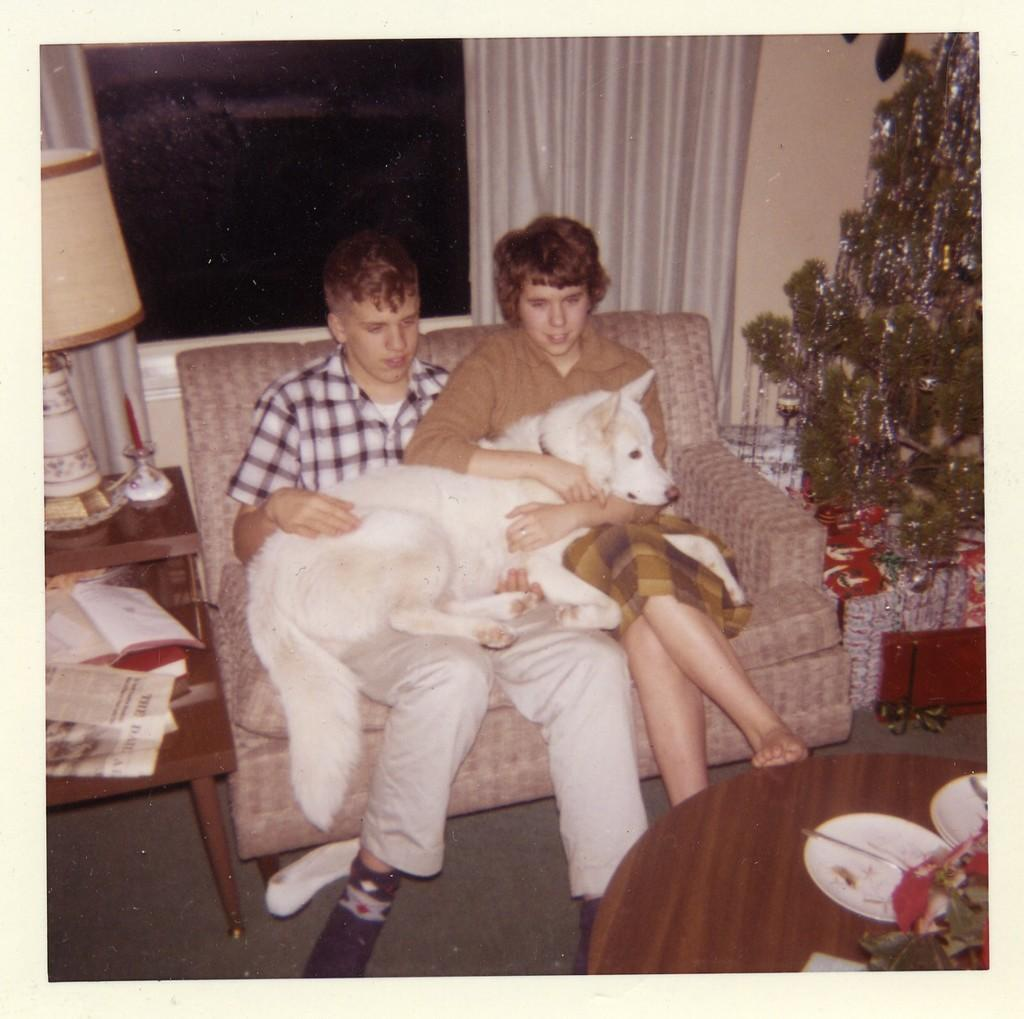How many people are in the image? There are two persons in the image. What are the persons doing in the image? The persons are sitting on a sofa and holding a dog on their laps. What is in front of the persons? There is a table in front of the persons. What can be seen in the right corner of the image? There is a Christmas tree in the right corner of the image. What type of iron is being used to press the quilt in the image? There is no iron or quilt present in the image. Is the hospital visible in the image? There is no hospital present in the image. 